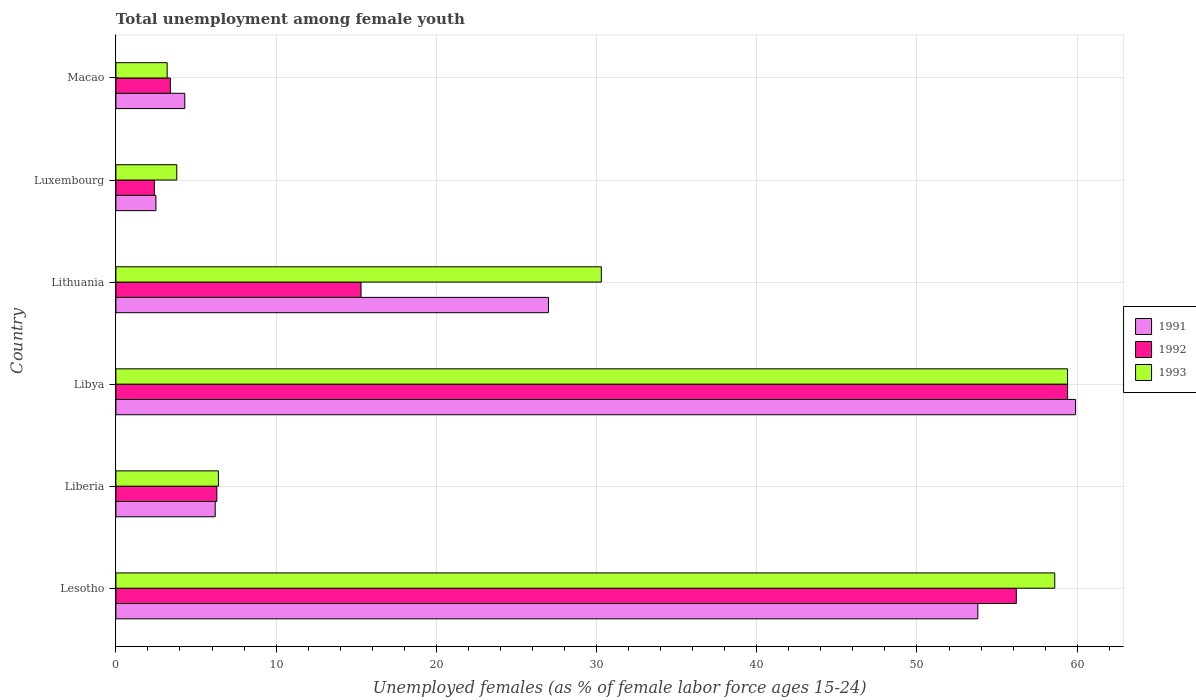How many different coloured bars are there?
Give a very brief answer. 3. Are the number of bars per tick equal to the number of legend labels?
Ensure brevity in your answer.  Yes. How many bars are there on the 6th tick from the top?
Provide a succinct answer. 3. What is the label of the 2nd group of bars from the top?
Make the answer very short. Luxembourg. What is the percentage of unemployed females in in 1992 in Lithuania?
Your response must be concise. 15.3. Across all countries, what is the maximum percentage of unemployed females in in 1993?
Offer a very short reply. 59.4. Across all countries, what is the minimum percentage of unemployed females in in 1993?
Keep it short and to the point. 3.2. In which country was the percentage of unemployed females in in 1992 maximum?
Give a very brief answer. Libya. In which country was the percentage of unemployed females in in 1991 minimum?
Your response must be concise. Luxembourg. What is the total percentage of unemployed females in in 1991 in the graph?
Give a very brief answer. 153.7. What is the difference between the percentage of unemployed females in in 1991 in Lesotho and that in Liberia?
Provide a short and direct response. 47.6. What is the difference between the percentage of unemployed females in in 1993 in Lesotho and the percentage of unemployed females in in 1991 in Macao?
Ensure brevity in your answer.  54.3. What is the average percentage of unemployed females in in 1991 per country?
Offer a terse response. 25.62. What is the difference between the percentage of unemployed females in in 1991 and percentage of unemployed females in in 1992 in Lithuania?
Your answer should be compact. 11.7. In how many countries, is the percentage of unemployed females in in 1992 greater than 6 %?
Your answer should be compact. 4. What is the ratio of the percentage of unemployed females in in 1993 in Lithuania to that in Luxembourg?
Keep it short and to the point. 7.97. Is the difference between the percentage of unemployed females in in 1991 in Lesotho and Luxembourg greater than the difference between the percentage of unemployed females in in 1992 in Lesotho and Luxembourg?
Make the answer very short. No. What is the difference between the highest and the second highest percentage of unemployed females in in 1991?
Offer a very short reply. 6.1. What is the difference between the highest and the lowest percentage of unemployed females in in 1993?
Keep it short and to the point. 56.2. How many bars are there?
Offer a terse response. 18. Are all the bars in the graph horizontal?
Keep it short and to the point. Yes. What is the difference between two consecutive major ticks on the X-axis?
Offer a terse response. 10. What is the title of the graph?
Provide a short and direct response. Total unemployment among female youth. What is the label or title of the X-axis?
Your answer should be very brief. Unemployed females (as % of female labor force ages 15-24). What is the Unemployed females (as % of female labor force ages 15-24) of 1991 in Lesotho?
Your response must be concise. 53.8. What is the Unemployed females (as % of female labor force ages 15-24) in 1992 in Lesotho?
Your answer should be compact. 56.2. What is the Unemployed females (as % of female labor force ages 15-24) in 1993 in Lesotho?
Your response must be concise. 58.6. What is the Unemployed females (as % of female labor force ages 15-24) in 1991 in Liberia?
Your response must be concise. 6.2. What is the Unemployed females (as % of female labor force ages 15-24) of 1992 in Liberia?
Offer a terse response. 6.3. What is the Unemployed females (as % of female labor force ages 15-24) in 1993 in Liberia?
Offer a terse response. 6.4. What is the Unemployed females (as % of female labor force ages 15-24) in 1991 in Libya?
Give a very brief answer. 59.9. What is the Unemployed females (as % of female labor force ages 15-24) of 1992 in Libya?
Your answer should be compact. 59.4. What is the Unemployed females (as % of female labor force ages 15-24) in 1993 in Libya?
Your answer should be very brief. 59.4. What is the Unemployed females (as % of female labor force ages 15-24) in 1992 in Lithuania?
Provide a succinct answer. 15.3. What is the Unemployed females (as % of female labor force ages 15-24) in 1993 in Lithuania?
Offer a terse response. 30.3. What is the Unemployed females (as % of female labor force ages 15-24) in 1991 in Luxembourg?
Offer a terse response. 2.5. What is the Unemployed females (as % of female labor force ages 15-24) in 1992 in Luxembourg?
Your answer should be compact. 2.4. What is the Unemployed females (as % of female labor force ages 15-24) of 1993 in Luxembourg?
Ensure brevity in your answer.  3.8. What is the Unemployed females (as % of female labor force ages 15-24) of 1991 in Macao?
Your answer should be compact. 4.3. What is the Unemployed females (as % of female labor force ages 15-24) of 1992 in Macao?
Make the answer very short. 3.4. What is the Unemployed females (as % of female labor force ages 15-24) of 1993 in Macao?
Ensure brevity in your answer.  3.2. Across all countries, what is the maximum Unemployed females (as % of female labor force ages 15-24) of 1991?
Make the answer very short. 59.9. Across all countries, what is the maximum Unemployed females (as % of female labor force ages 15-24) of 1992?
Make the answer very short. 59.4. Across all countries, what is the maximum Unemployed females (as % of female labor force ages 15-24) of 1993?
Ensure brevity in your answer.  59.4. Across all countries, what is the minimum Unemployed females (as % of female labor force ages 15-24) in 1991?
Provide a succinct answer. 2.5. Across all countries, what is the minimum Unemployed females (as % of female labor force ages 15-24) in 1992?
Offer a very short reply. 2.4. Across all countries, what is the minimum Unemployed females (as % of female labor force ages 15-24) of 1993?
Ensure brevity in your answer.  3.2. What is the total Unemployed females (as % of female labor force ages 15-24) of 1991 in the graph?
Your answer should be compact. 153.7. What is the total Unemployed females (as % of female labor force ages 15-24) of 1992 in the graph?
Offer a terse response. 143. What is the total Unemployed females (as % of female labor force ages 15-24) in 1993 in the graph?
Your answer should be very brief. 161.7. What is the difference between the Unemployed females (as % of female labor force ages 15-24) of 1991 in Lesotho and that in Liberia?
Offer a terse response. 47.6. What is the difference between the Unemployed females (as % of female labor force ages 15-24) of 1992 in Lesotho and that in Liberia?
Offer a terse response. 49.9. What is the difference between the Unemployed females (as % of female labor force ages 15-24) of 1993 in Lesotho and that in Liberia?
Offer a very short reply. 52.2. What is the difference between the Unemployed females (as % of female labor force ages 15-24) of 1992 in Lesotho and that in Libya?
Keep it short and to the point. -3.2. What is the difference between the Unemployed females (as % of female labor force ages 15-24) in 1993 in Lesotho and that in Libya?
Offer a terse response. -0.8. What is the difference between the Unemployed females (as % of female labor force ages 15-24) in 1991 in Lesotho and that in Lithuania?
Offer a very short reply. 26.8. What is the difference between the Unemployed females (as % of female labor force ages 15-24) in 1992 in Lesotho and that in Lithuania?
Your answer should be very brief. 40.9. What is the difference between the Unemployed females (as % of female labor force ages 15-24) in 1993 in Lesotho and that in Lithuania?
Offer a terse response. 28.3. What is the difference between the Unemployed females (as % of female labor force ages 15-24) in 1991 in Lesotho and that in Luxembourg?
Give a very brief answer. 51.3. What is the difference between the Unemployed females (as % of female labor force ages 15-24) in 1992 in Lesotho and that in Luxembourg?
Offer a terse response. 53.8. What is the difference between the Unemployed females (as % of female labor force ages 15-24) in 1993 in Lesotho and that in Luxembourg?
Make the answer very short. 54.8. What is the difference between the Unemployed females (as % of female labor force ages 15-24) of 1991 in Lesotho and that in Macao?
Ensure brevity in your answer.  49.5. What is the difference between the Unemployed females (as % of female labor force ages 15-24) of 1992 in Lesotho and that in Macao?
Ensure brevity in your answer.  52.8. What is the difference between the Unemployed females (as % of female labor force ages 15-24) of 1993 in Lesotho and that in Macao?
Ensure brevity in your answer.  55.4. What is the difference between the Unemployed females (as % of female labor force ages 15-24) of 1991 in Liberia and that in Libya?
Ensure brevity in your answer.  -53.7. What is the difference between the Unemployed females (as % of female labor force ages 15-24) in 1992 in Liberia and that in Libya?
Give a very brief answer. -53.1. What is the difference between the Unemployed females (as % of female labor force ages 15-24) of 1993 in Liberia and that in Libya?
Your answer should be very brief. -53. What is the difference between the Unemployed females (as % of female labor force ages 15-24) in 1991 in Liberia and that in Lithuania?
Keep it short and to the point. -20.8. What is the difference between the Unemployed females (as % of female labor force ages 15-24) of 1992 in Liberia and that in Lithuania?
Give a very brief answer. -9. What is the difference between the Unemployed females (as % of female labor force ages 15-24) of 1993 in Liberia and that in Lithuania?
Your answer should be very brief. -23.9. What is the difference between the Unemployed females (as % of female labor force ages 15-24) in 1992 in Liberia and that in Luxembourg?
Keep it short and to the point. 3.9. What is the difference between the Unemployed females (as % of female labor force ages 15-24) in 1993 in Liberia and that in Luxembourg?
Make the answer very short. 2.6. What is the difference between the Unemployed females (as % of female labor force ages 15-24) of 1991 in Liberia and that in Macao?
Offer a terse response. 1.9. What is the difference between the Unemployed females (as % of female labor force ages 15-24) of 1991 in Libya and that in Lithuania?
Offer a very short reply. 32.9. What is the difference between the Unemployed females (as % of female labor force ages 15-24) in 1992 in Libya and that in Lithuania?
Ensure brevity in your answer.  44.1. What is the difference between the Unemployed females (as % of female labor force ages 15-24) of 1993 in Libya and that in Lithuania?
Your answer should be very brief. 29.1. What is the difference between the Unemployed females (as % of female labor force ages 15-24) in 1991 in Libya and that in Luxembourg?
Your answer should be compact. 57.4. What is the difference between the Unemployed females (as % of female labor force ages 15-24) in 1993 in Libya and that in Luxembourg?
Keep it short and to the point. 55.6. What is the difference between the Unemployed females (as % of female labor force ages 15-24) of 1991 in Libya and that in Macao?
Your response must be concise. 55.6. What is the difference between the Unemployed females (as % of female labor force ages 15-24) of 1993 in Libya and that in Macao?
Provide a short and direct response. 56.2. What is the difference between the Unemployed females (as % of female labor force ages 15-24) of 1991 in Lithuania and that in Luxembourg?
Provide a succinct answer. 24.5. What is the difference between the Unemployed females (as % of female labor force ages 15-24) in 1992 in Lithuania and that in Luxembourg?
Keep it short and to the point. 12.9. What is the difference between the Unemployed females (as % of female labor force ages 15-24) in 1993 in Lithuania and that in Luxembourg?
Offer a very short reply. 26.5. What is the difference between the Unemployed females (as % of female labor force ages 15-24) of 1991 in Lithuania and that in Macao?
Ensure brevity in your answer.  22.7. What is the difference between the Unemployed females (as % of female labor force ages 15-24) of 1993 in Lithuania and that in Macao?
Your answer should be very brief. 27.1. What is the difference between the Unemployed females (as % of female labor force ages 15-24) of 1991 in Luxembourg and that in Macao?
Provide a short and direct response. -1.8. What is the difference between the Unemployed females (as % of female labor force ages 15-24) of 1991 in Lesotho and the Unemployed females (as % of female labor force ages 15-24) of 1992 in Liberia?
Keep it short and to the point. 47.5. What is the difference between the Unemployed females (as % of female labor force ages 15-24) in 1991 in Lesotho and the Unemployed females (as % of female labor force ages 15-24) in 1993 in Liberia?
Offer a very short reply. 47.4. What is the difference between the Unemployed females (as % of female labor force ages 15-24) of 1992 in Lesotho and the Unemployed females (as % of female labor force ages 15-24) of 1993 in Liberia?
Give a very brief answer. 49.8. What is the difference between the Unemployed females (as % of female labor force ages 15-24) of 1991 in Lesotho and the Unemployed females (as % of female labor force ages 15-24) of 1992 in Libya?
Make the answer very short. -5.6. What is the difference between the Unemployed females (as % of female labor force ages 15-24) in 1991 in Lesotho and the Unemployed females (as % of female labor force ages 15-24) in 1993 in Libya?
Ensure brevity in your answer.  -5.6. What is the difference between the Unemployed females (as % of female labor force ages 15-24) in 1992 in Lesotho and the Unemployed females (as % of female labor force ages 15-24) in 1993 in Libya?
Offer a very short reply. -3.2. What is the difference between the Unemployed females (as % of female labor force ages 15-24) of 1991 in Lesotho and the Unemployed females (as % of female labor force ages 15-24) of 1992 in Lithuania?
Make the answer very short. 38.5. What is the difference between the Unemployed females (as % of female labor force ages 15-24) of 1992 in Lesotho and the Unemployed females (as % of female labor force ages 15-24) of 1993 in Lithuania?
Offer a terse response. 25.9. What is the difference between the Unemployed females (as % of female labor force ages 15-24) of 1991 in Lesotho and the Unemployed females (as % of female labor force ages 15-24) of 1992 in Luxembourg?
Give a very brief answer. 51.4. What is the difference between the Unemployed females (as % of female labor force ages 15-24) of 1991 in Lesotho and the Unemployed females (as % of female labor force ages 15-24) of 1993 in Luxembourg?
Ensure brevity in your answer.  50. What is the difference between the Unemployed females (as % of female labor force ages 15-24) of 1992 in Lesotho and the Unemployed females (as % of female labor force ages 15-24) of 1993 in Luxembourg?
Your answer should be very brief. 52.4. What is the difference between the Unemployed females (as % of female labor force ages 15-24) of 1991 in Lesotho and the Unemployed females (as % of female labor force ages 15-24) of 1992 in Macao?
Give a very brief answer. 50.4. What is the difference between the Unemployed females (as % of female labor force ages 15-24) in 1991 in Lesotho and the Unemployed females (as % of female labor force ages 15-24) in 1993 in Macao?
Offer a terse response. 50.6. What is the difference between the Unemployed females (as % of female labor force ages 15-24) in 1992 in Lesotho and the Unemployed females (as % of female labor force ages 15-24) in 1993 in Macao?
Offer a very short reply. 53. What is the difference between the Unemployed females (as % of female labor force ages 15-24) of 1991 in Liberia and the Unemployed females (as % of female labor force ages 15-24) of 1992 in Libya?
Provide a short and direct response. -53.2. What is the difference between the Unemployed females (as % of female labor force ages 15-24) of 1991 in Liberia and the Unemployed females (as % of female labor force ages 15-24) of 1993 in Libya?
Your answer should be very brief. -53.2. What is the difference between the Unemployed females (as % of female labor force ages 15-24) of 1992 in Liberia and the Unemployed females (as % of female labor force ages 15-24) of 1993 in Libya?
Provide a succinct answer. -53.1. What is the difference between the Unemployed females (as % of female labor force ages 15-24) in 1991 in Liberia and the Unemployed females (as % of female labor force ages 15-24) in 1992 in Lithuania?
Keep it short and to the point. -9.1. What is the difference between the Unemployed females (as % of female labor force ages 15-24) in 1991 in Liberia and the Unemployed females (as % of female labor force ages 15-24) in 1993 in Lithuania?
Make the answer very short. -24.1. What is the difference between the Unemployed females (as % of female labor force ages 15-24) of 1991 in Liberia and the Unemployed females (as % of female labor force ages 15-24) of 1992 in Luxembourg?
Provide a succinct answer. 3.8. What is the difference between the Unemployed females (as % of female labor force ages 15-24) in 1991 in Liberia and the Unemployed females (as % of female labor force ages 15-24) in 1992 in Macao?
Provide a succinct answer. 2.8. What is the difference between the Unemployed females (as % of female labor force ages 15-24) in 1992 in Liberia and the Unemployed females (as % of female labor force ages 15-24) in 1993 in Macao?
Your answer should be compact. 3.1. What is the difference between the Unemployed females (as % of female labor force ages 15-24) of 1991 in Libya and the Unemployed females (as % of female labor force ages 15-24) of 1992 in Lithuania?
Your answer should be very brief. 44.6. What is the difference between the Unemployed females (as % of female labor force ages 15-24) in 1991 in Libya and the Unemployed females (as % of female labor force ages 15-24) in 1993 in Lithuania?
Your answer should be very brief. 29.6. What is the difference between the Unemployed females (as % of female labor force ages 15-24) in 1992 in Libya and the Unemployed females (as % of female labor force ages 15-24) in 1993 in Lithuania?
Make the answer very short. 29.1. What is the difference between the Unemployed females (as % of female labor force ages 15-24) of 1991 in Libya and the Unemployed females (as % of female labor force ages 15-24) of 1992 in Luxembourg?
Offer a very short reply. 57.5. What is the difference between the Unemployed females (as % of female labor force ages 15-24) of 1991 in Libya and the Unemployed females (as % of female labor force ages 15-24) of 1993 in Luxembourg?
Your answer should be compact. 56.1. What is the difference between the Unemployed females (as % of female labor force ages 15-24) of 1992 in Libya and the Unemployed females (as % of female labor force ages 15-24) of 1993 in Luxembourg?
Your response must be concise. 55.6. What is the difference between the Unemployed females (as % of female labor force ages 15-24) of 1991 in Libya and the Unemployed females (as % of female labor force ages 15-24) of 1992 in Macao?
Offer a very short reply. 56.5. What is the difference between the Unemployed females (as % of female labor force ages 15-24) in 1991 in Libya and the Unemployed females (as % of female labor force ages 15-24) in 1993 in Macao?
Provide a short and direct response. 56.7. What is the difference between the Unemployed females (as % of female labor force ages 15-24) of 1992 in Libya and the Unemployed females (as % of female labor force ages 15-24) of 1993 in Macao?
Offer a terse response. 56.2. What is the difference between the Unemployed females (as % of female labor force ages 15-24) of 1991 in Lithuania and the Unemployed females (as % of female labor force ages 15-24) of 1992 in Luxembourg?
Your response must be concise. 24.6. What is the difference between the Unemployed females (as % of female labor force ages 15-24) of 1991 in Lithuania and the Unemployed females (as % of female labor force ages 15-24) of 1993 in Luxembourg?
Provide a short and direct response. 23.2. What is the difference between the Unemployed females (as % of female labor force ages 15-24) of 1991 in Lithuania and the Unemployed females (as % of female labor force ages 15-24) of 1992 in Macao?
Your answer should be very brief. 23.6. What is the difference between the Unemployed females (as % of female labor force ages 15-24) in 1991 in Lithuania and the Unemployed females (as % of female labor force ages 15-24) in 1993 in Macao?
Keep it short and to the point. 23.8. What is the difference between the Unemployed females (as % of female labor force ages 15-24) in 1991 in Luxembourg and the Unemployed females (as % of female labor force ages 15-24) in 1992 in Macao?
Keep it short and to the point. -0.9. What is the difference between the Unemployed females (as % of female labor force ages 15-24) of 1992 in Luxembourg and the Unemployed females (as % of female labor force ages 15-24) of 1993 in Macao?
Give a very brief answer. -0.8. What is the average Unemployed females (as % of female labor force ages 15-24) in 1991 per country?
Ensure brevity in your answer.  25.62. What is the average Unemployed females (as % of female labor force ages 15-24) in 1992 per country?
Offer a terse response. 23.83. What is the average Unemployed females (as % of female labor force ages 15-24) of 1993 per country?
Keep it short and to the point. 26.95. What is the difference between the Unemployed females (as % of female labor force ages 15-24) in 1991 and Unemployed females (as % of female labor force ages 15-24) in 1992 in Lesotho?
Give a very brief answer. -2.4. What is the difference between the Unemployed females (as % of female labor force ages 15-24) in 1991 and Unemployed females (as % of female labor force ages 15-24) in 1993 in Lesotho?
Offer a terse response. -4.8. What is the difference between the Unemployed females (as % of female labor force ages 15-24) in 1991 and Unemployed females (as % of female labor force ages 15-24) in 1992 in Liberia?
Provide a succinct answer. -0.1. What is the difference between the Unemployed females (as % of female labor force ages 15-24) of 1991 and Unemployed females (as % of female labor force ages 15-24) of 1992 in Lithuania?
Offer a terse response. 11.7. What is the difference between the Unemployed females (as % of female labor force ages 15-24) of 1991 and Unemployed females (as % of female labor force ages 15-24) of 1993 in Lithuania?
Give a very brief answer. -3.3. What is the difference between the Unemployed females (as % of female labor force ages 15-24) of 1992 and Unemployed females (as % of female labor force ages 15-24) of 1993 in Lithuania?
Make the answer very short. -15. What is the difference between the Unemployed females (as % of female labor force ages 15-24) of 1991 and Unemployed females (as % of female labor force ages 15-24) of 1992 in Luxembourg?
Provide a succinct answer. 0.1. What is the difference between the Unemployed females (as % of female labor force ages 15-24) of 1991 and Unemployed females (as % of female labor force ages 15-24) of 1993 in Macao?
Make the answer very short. 1.1. What is the difference between the Unemployed females (as % of female labor force ages 15-24) of 1992 and Unemployed females (as % of female labor force ages 15-24) of 1993 in Macao?
Provide a short and direct response. 0.2. What is the ratio of the Unemployed females (as % of female labor force ages 15-24) in 1991 in Lesotho to that in Liberia?
Your response must be concise. 8.68. What is the ratio of the Unemployed females (as % of female labor force ages 15-24) in 1992 in Lesotho to that in Liberia?
Provide a succinct answer. 8.92. What is the ratio of the Unemployed females (as % of female labor force ages 15-24) of 1993 in Lesotho to that in Liberia?
Offer a very short reply. 9.16. What is the ratio of the Unemployed females (as % of female labor force ages 15-24) of 1991 in Lesotho to that in Libya?
Make the answer very short. 0.9. What is the ratio of the Unemployed females (as % of female labor force ages 15-24) in 1992 in Lesotho to that in Libya?
Provide a succinct answer. 0.95. What is the ratio of the Unemployed females (as % of female labor force ages 15-24) in 1993 in Lesotho to that in Libya?
Ensure brevity in your answer.  0.99. What is the ratio of the Unemployed females (as % of female labor force ages 15-24) of 1991 in Lesotho to that in Lithuania?
Offer a very short reply. 1.99. What is the ratio of the Unemployed females (as % of female labor force ages 15-24) in 1992 in Lesotho to that in Lithuania?
Offer a very short reply. 3.67. What is the ratio of the Unemployed females (as % of female labor force ages 15-24) of 1993 in Lesotho to that in Lithuania?
Make the answer very short. 1.93. What is the ratio of the Unemployed females (as % of female labor force ages 15-24) of 1991 in Lesotho to that in Luxembourg?
Provide a succinct answer. 21.52. What is the ratio of the Unemployed females (as % of female labor force ages 15-24) in 1992 in Lesotho to that in Luxembourg?
Offer a terse response. 23.42. What is the ratio of the Unemployed females (as % of female labor force ages 15-24) in 1993 in Lesotho to that in Luxembourg?
Your response must be concise. 15.42. What is the ratio of the Unemployed females (as % of female labor force ages 15-24) in 1991 in Lesotho to that in Macao?
Your answer should be compact. 12.51. What is the ratio of the Unemployed females (as % of female labor force ages 15-24) in 1992 in Lesotho to that in Macao?
Your response must be concise. 16.53. What is the ratio of the Unemployed females (as % of female labor force ages 15-24) in 1993 in Lesotho to that in Macao?
Your response must be concise. 18.31. What is the ratio of the Unemployed females (as % of female labor force ages 15-24) of 1991 in Liberia to that in Libya?
Make the answer very short. 0.1. What is the ratio of the Unemployed females (as % of female labor force ages 15-24) of 1992 in Liberia to that in Libya?
Provide a short and direct response. 0.11. What is the ratio of the Unemployed females (as % of female labor force ages 15-24) in 1993 in Liberia to that in Libya?
Offer a terse response. 0.11. What is the ratio of the Unemployed females (as % of female labor force ages 15-24) in 1991 in Liberia to that in Lithuania?
Offer a very short reply. 0.23. What is the ratio of the Unemployed females (as % of female labor force ages 15-24) in 1992 in Liberia to that in Lithuania?
Provide a succinct answer. 0.41. What is the ratio of the Unemployed females (as % of female labor force ages 15-24) in 1993 in Liberia to that in Lithuania?
Make the answer very short. 0.21. What is the ratio of the Unemployed females (as % of female labor force ages 15-24) in 1991 in Liberia to that in Luxembourg?
Provide a short and direct response. 2.48. What is the ratio of the Unemployed females (as % of female labor force ages 15-24) of 1992 in Liberia to that in Luxembourg?
Offer a very short reply. 2.62. What is the ratio of the Unemployed females (as % of female labor force ages 15-24) in 1993 in Liberia to that in Luxembourg?
Provide a succinct answer. 1.68. What is the ratio of the Unemployed females (as % of female labor force ages 15-24) in 1991 in Liberia to that in Macao?
Your response must be concise. 1.44. What is the ratio of the Unemployed females (as % of female labor force ages 15-24) in 1992 in Liberia to that in Macao?
Give a very brief answer. 1.85. What is the ratio of the Unemployed females (as % of female labor force ages 15-24) of 1993 in Liberia to that in Macao?
Ensure brevity in your answer.  2. What is the ratio of the Unemployed females (as % of female labor force ages 15-24) in 1991 in Libya to that in Lithuania?
Provide a succinct answer. 2.22. What is the ratio of the Unemployed females (as % of female labor force ages 15-24) in 1992 in Libya to that in Lithuania?
Offer a very short reply. 3.88. What is the ratio of the Unemployed females (as % of female labor force ages 15-24) of 1993 in Libya to that in Lithuania?
Offer a very short reply. 1.96. What is the ratio of the Unemployed females (as % of female labor force ages 15-24) in 1991 in Libya to that in Luxembourg?
Provide a succinct answer. 23.96. What is the ratio of the Unemployed females (as % of female labor force ages 15-24) in 1992 in Libya to that in Luxembourg?
Offer a very short reply. 24.75. What is the ratio of the Unemployed females (as % of female labor force ages 15-24) in 1993 in Libya to that in Luxembourg?
Offer a very short reply. 15.63. What is the ratio of the Unemployed females (as % of female labor force ages 15-24) of 1991 in Libya to that in Macao?
Ensure brevity in your answer.  13.93. What is the ratio of the Unemployed females (as % of female labor force ages 15-24) of 1992 in Libya to that in Macao?
Provide a succinct answer. 17.47. What is the ratio of the Unemployed females (as % of female labor force ages 15-24) of 1993 in Libya to that in Macao?
Your response must be concise. 18.56. What is the ratio of the Unemployed females (as % of female labor force ages 15-24) in 1992 in Lithuania to that in Luxembourg?
Ensure brevity in your answer.  6.38. What is the ratio of the Unemployed females (as % of female labor force ages 15-24) of 1993 in Lithuania to that in Luxembourg?
Offer a terse response. 7.97. What is the ratio of the Unemployed females (as % of female labor force ages 15-24) of 1991 in Lithuania to that in Macao?
Make the answer very short. 6.28. What is the ratio of the Unemployed females (as % of female labor force ages 15-24) of 1992 in Lithuania to that in Macao?
Offer a terse response. 4.5. What is the ratio of the Unemployed females (as % of female labor force ages 15-24) in 1993 in Lithuania to that in Macao?
Provide a succinct answer. 9.47. What is the ratio of the Unemployed females (as % of female labor force ages 15-24) in 1991 in Luxembourg to that in Macao?
Keep it short and to the point. 0.58. What is the ratio of the Unemployed females (as % of female labor force ages 15-24) in 1992 in Luxembourg to that in Macao?
Keep it short and to the point. 0.71. What is the ratio of the Unemployed females (as % of female labor force ages 15-24) of 1993 in Luxembourg to that in Macao?
Offer a terse response. 1.19. What is the difference between the highest and the second highest Unemployed females (as % of female labor force ages 15-24) of 1992?
Provide a succinct answer. 3.2. What is the difference between the highest and the lowest Unemployed females (as % of female labor force ages 15-24) in 1991?
Your answer should be very brief. 57.4. What is the difference between the highest and the lowest Unemployed females (as % of female labor force ages 15-24) in 1993?
Offer a very short reply. 56.2. 